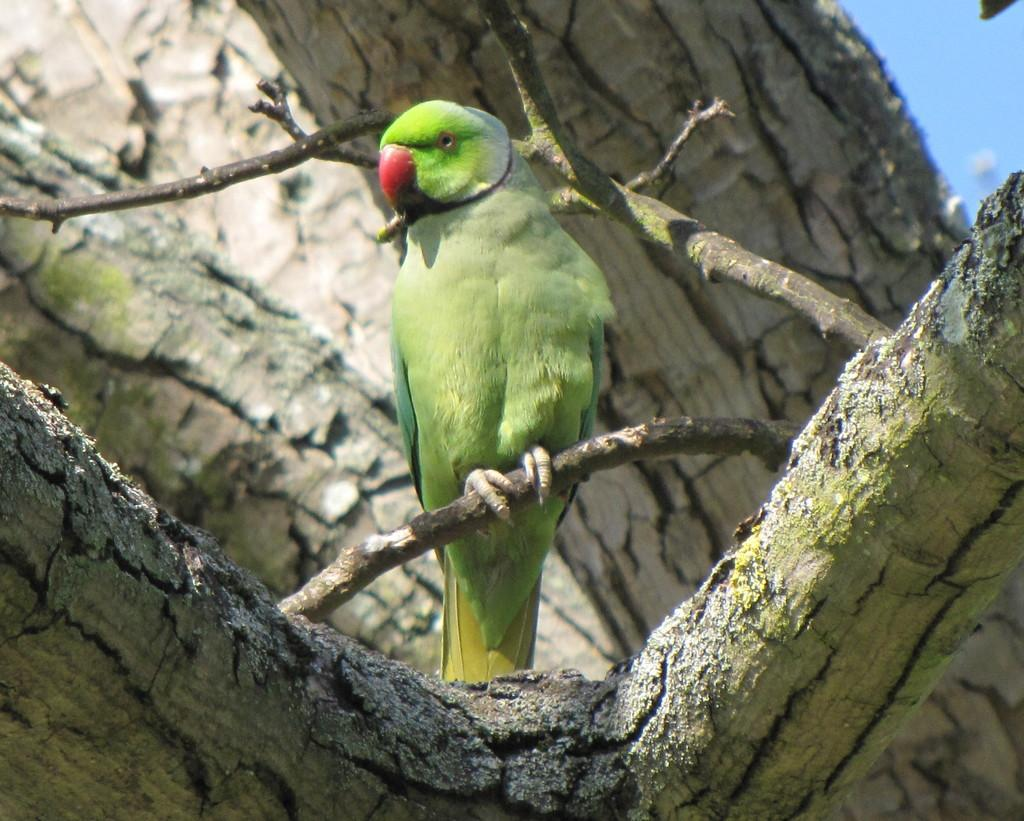What type of animal is in the image? There is a parrot in the image. Where is the parrot located? The parrot is on a tree. What type of bell can be seen hanging from the branch in the image? There is no bell present in the image; it only features a parrot on a tree. 